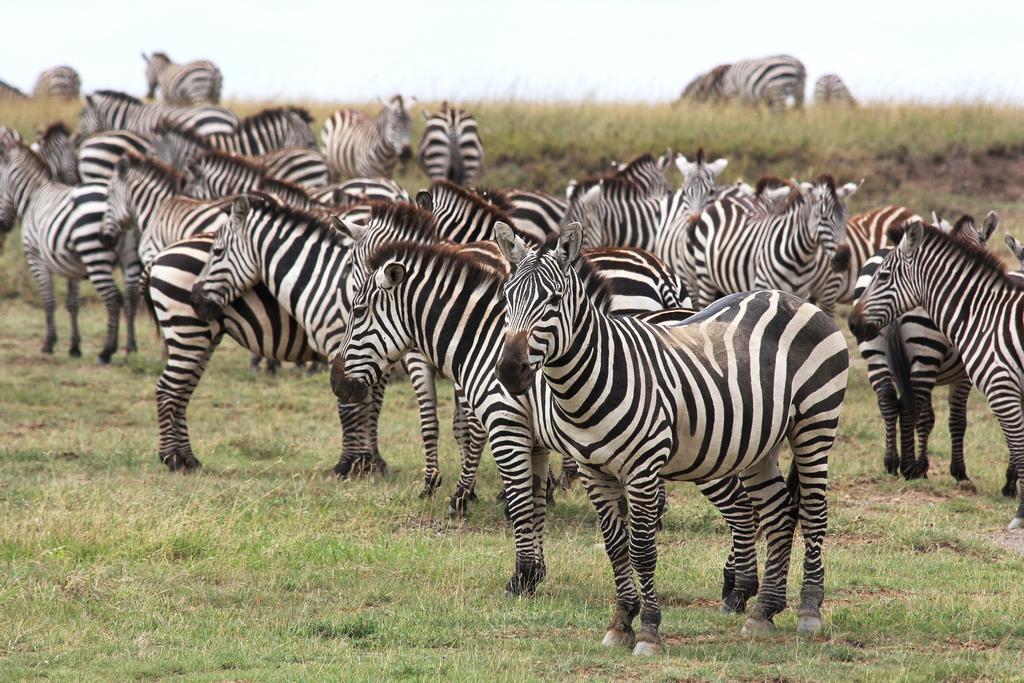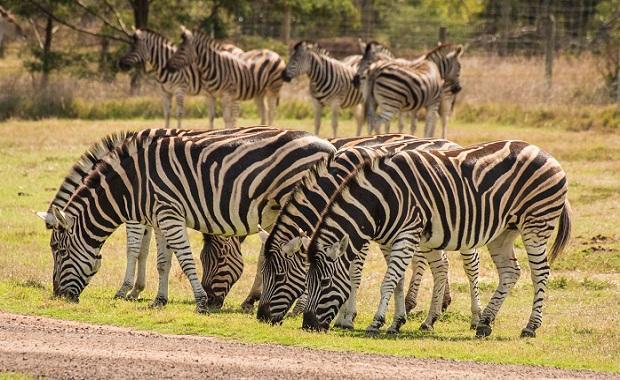The first image is the image on the left, the second image is the image on the right. Given the left and right images, does the statement "At least one image shows a row of zebras in similar poses in terms of the way their bodies are turned and their eyes are gazing." hold true? Answer yes or no. Yes. The first image is the image on the left, the second image is the image on the right. Assess this claim about the two images: "Some zebras are eating grass.". Correct or not? Answer yes or no. Yes. 